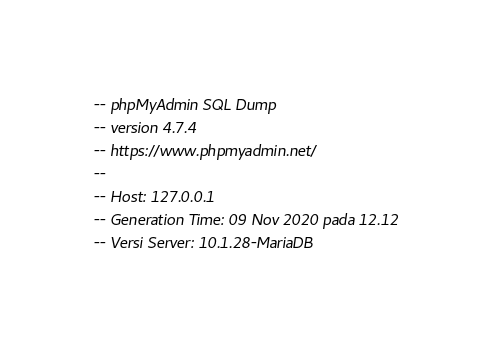<code> <loc_0><loc_0><loc_500><loc_500><_SQL_>-- phpMyAdmin SQL Dump
-- version 4.7.4
-- https://www.phpmyadmin.net/
--
-- Host: 127.0.0.1
-- Generation Time: 09 Nov 2020 pada 12.12
-- Versi Server: 10.1.28-MariaDB</code> 